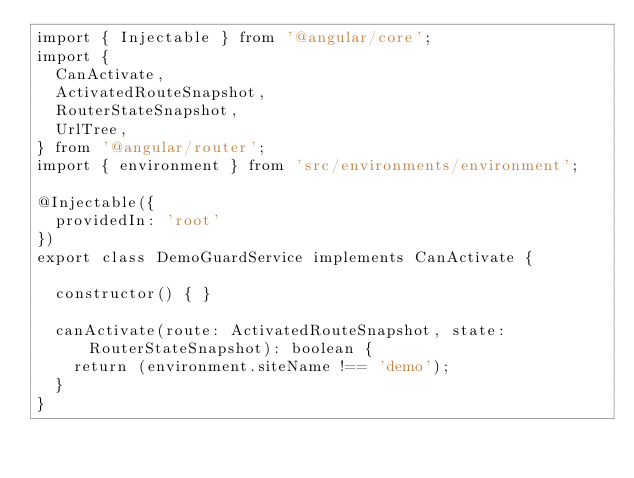Convert code to text. <code><loc_0><loc_0><loc_500><loc_500><_TypeScript_>import { Injectable } from '@angular/core';
import {
  CanActivate,
  ActivatedRouteSnapshot,
  RouterStateSnapshot,
  UrlTree,
} from '@angular/router';
import { environment } from 'src/environments/environment';

@Injectable({
  providedIn: 'root'
})
export class DemoGuardService implements CanActivate {

  constructor() { }

  canActivate(route: ActivatedRouteSnapshot, state: RouterStateSnapshot): boolean {
    return (environment.siteName !== 'demo');
  }
}
</code> 